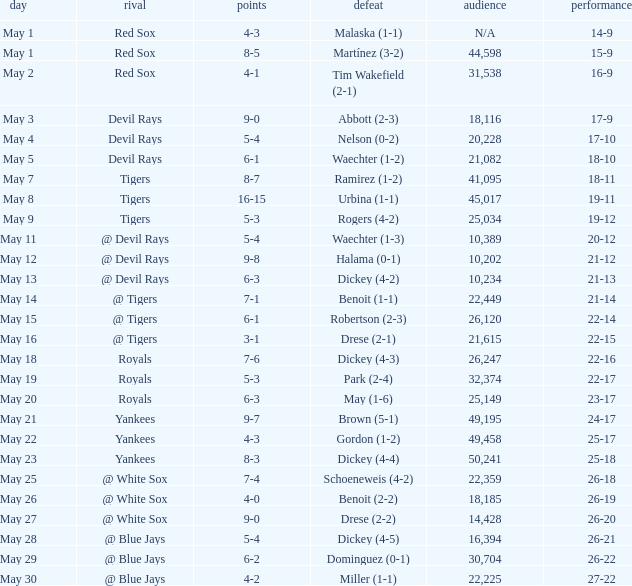What was the record at the game attended by 10,389? 20-12. 